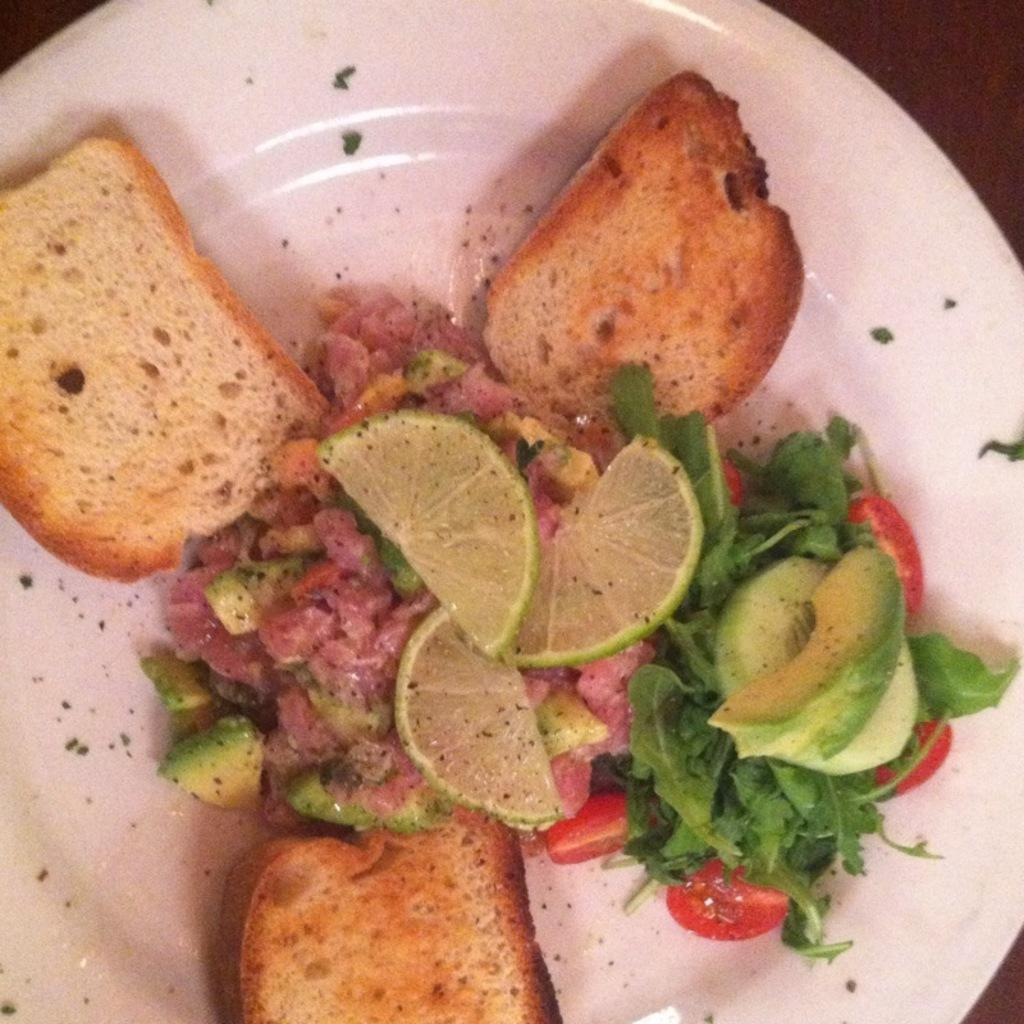What is on the plate that is visible in the image? The plate contains lemon slices, vegetable leaves, tomato slices, and cucumber. What type of food can be seen on the plate? There is food on the surface of the plate, including lemon slices, vegetable leaves, tomato slices, and cucumber. How many feathers are on the plate in the image? There are no feathers present on the plate in the image. What type of cat can be seen sitting next to the plate in the image? There is no cat present in the image. 